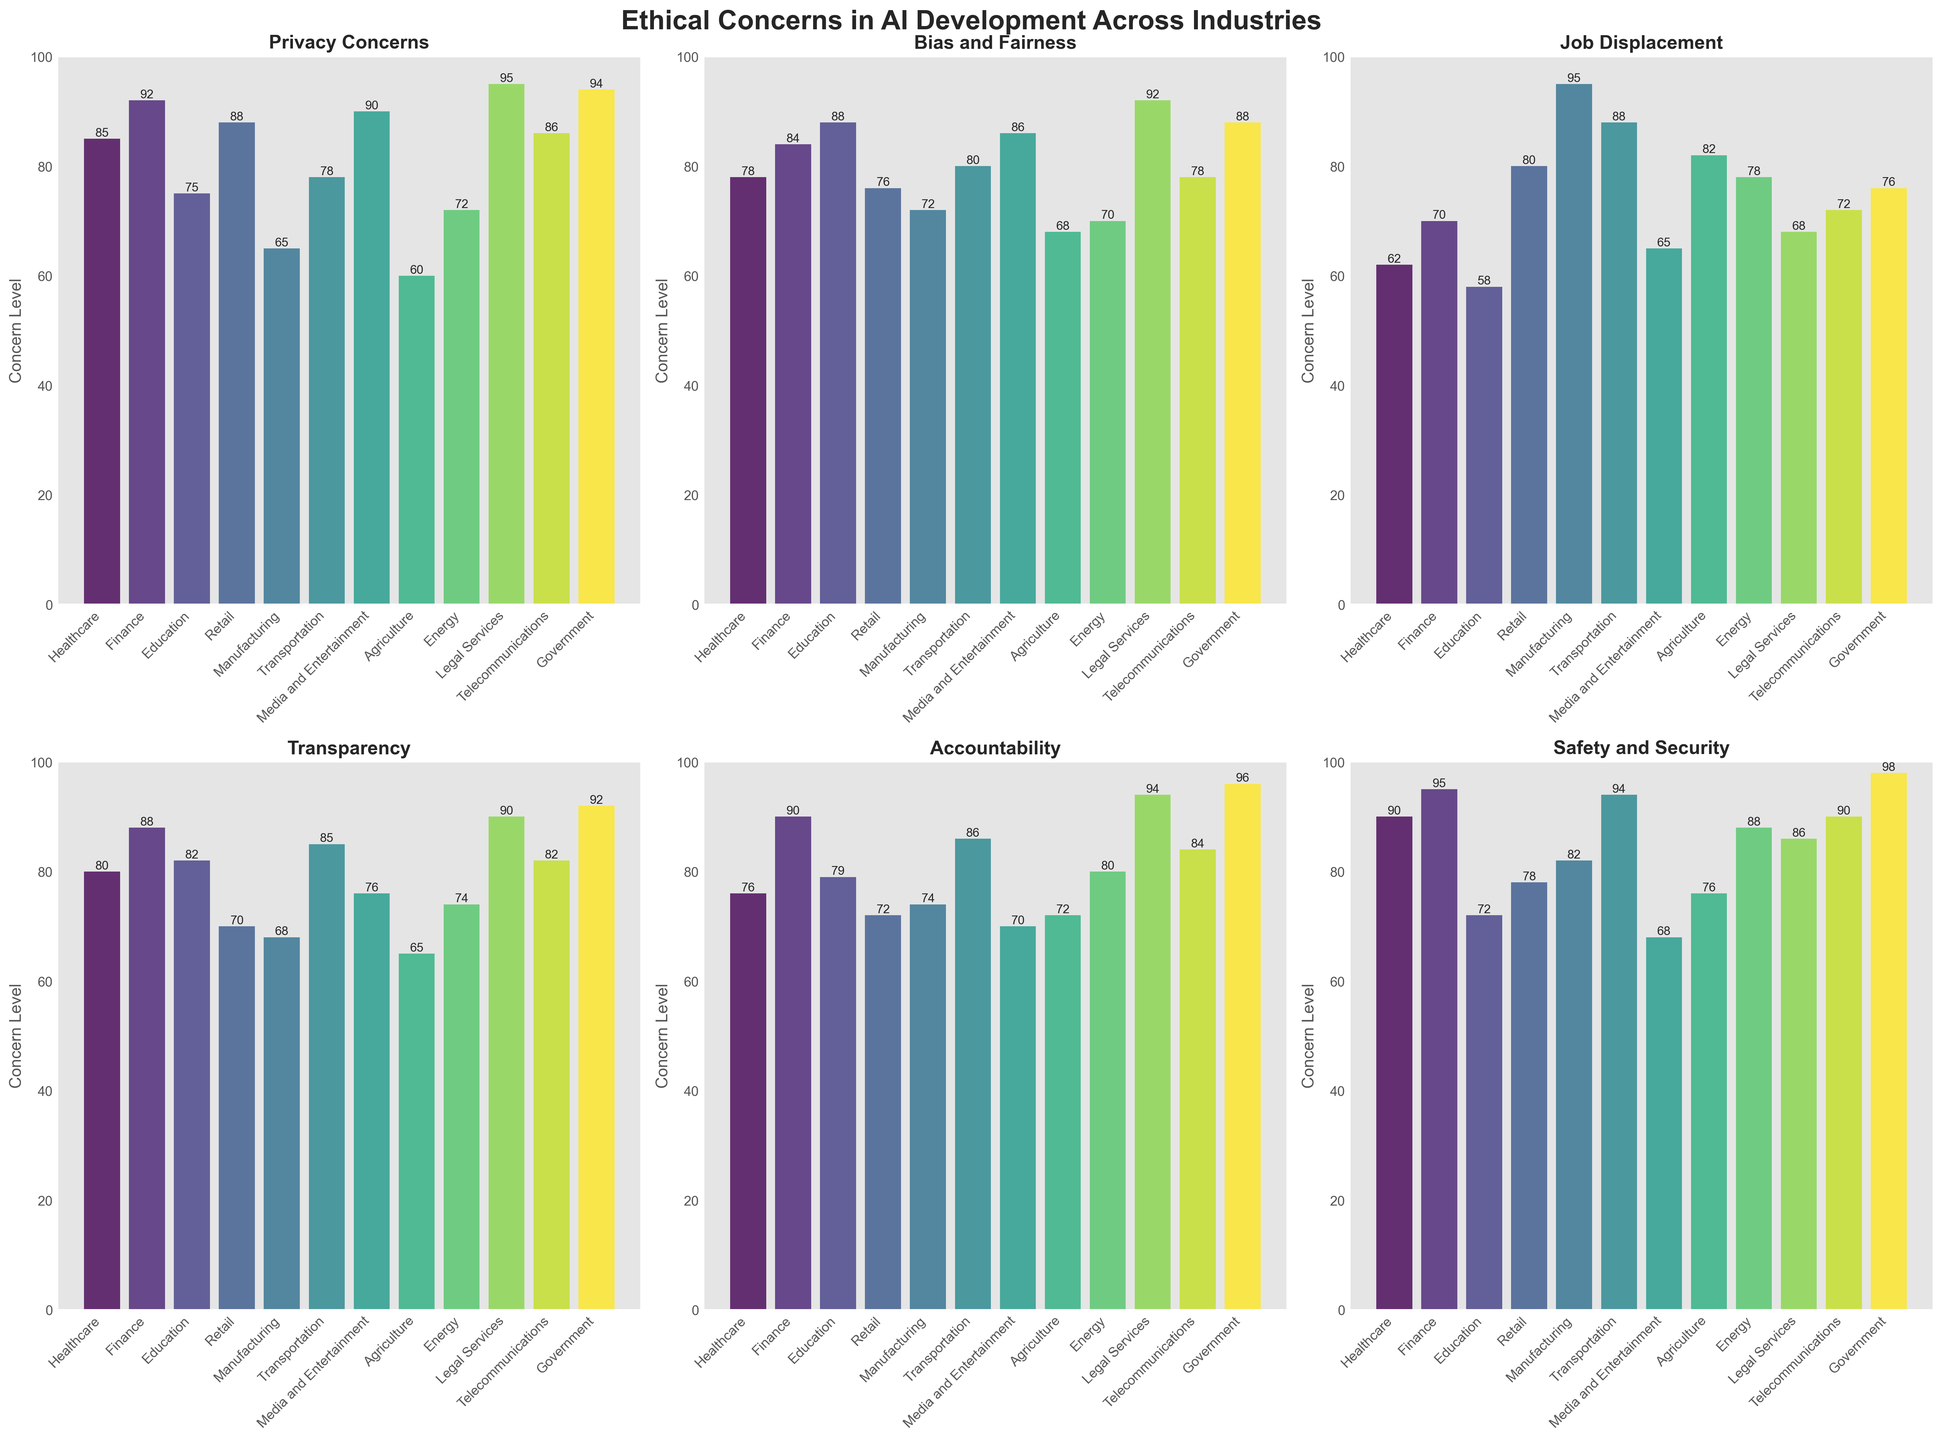Which industry exhibits the highest level of Privacy Concerns? Look for the bar with the highest height in the Privacy Concerns subplot. The Legal Services bar is the tallest, indicating the highest level.
Answer: Legal Services What is the difference in Job Displacement concerns between Manufacturing and Retail? Find the heights of the bars corresponding to Manufacturing and Retail in the Job Displacement subplot. Manufacturing has a height of 95, while Retail has 80. Subtract 80 from 95.
Answer: 15 Which industry has the lowest level of concerns in Safety and Security? Identify the shortest bar in the Safety and Security subplot. Media and Entertainment has the shortest bar at a height of 68.
Answer: Media and Entertainment What's the average level of Transparency concerns across all industries? Sum the height values for Transparency concerns across all industries (80+88+82+70+68+85+76+65+74+90+82+92) = 952. Divide by the number of industries (12).
Answer: 79.33 Which two industries have exactly equal levels of concerns in Accountability? Compare the heights of the bars in the Accountability subplot. Retail and Agriculture both have bars with a height of 72.
Answer: Retail and Agriculture 